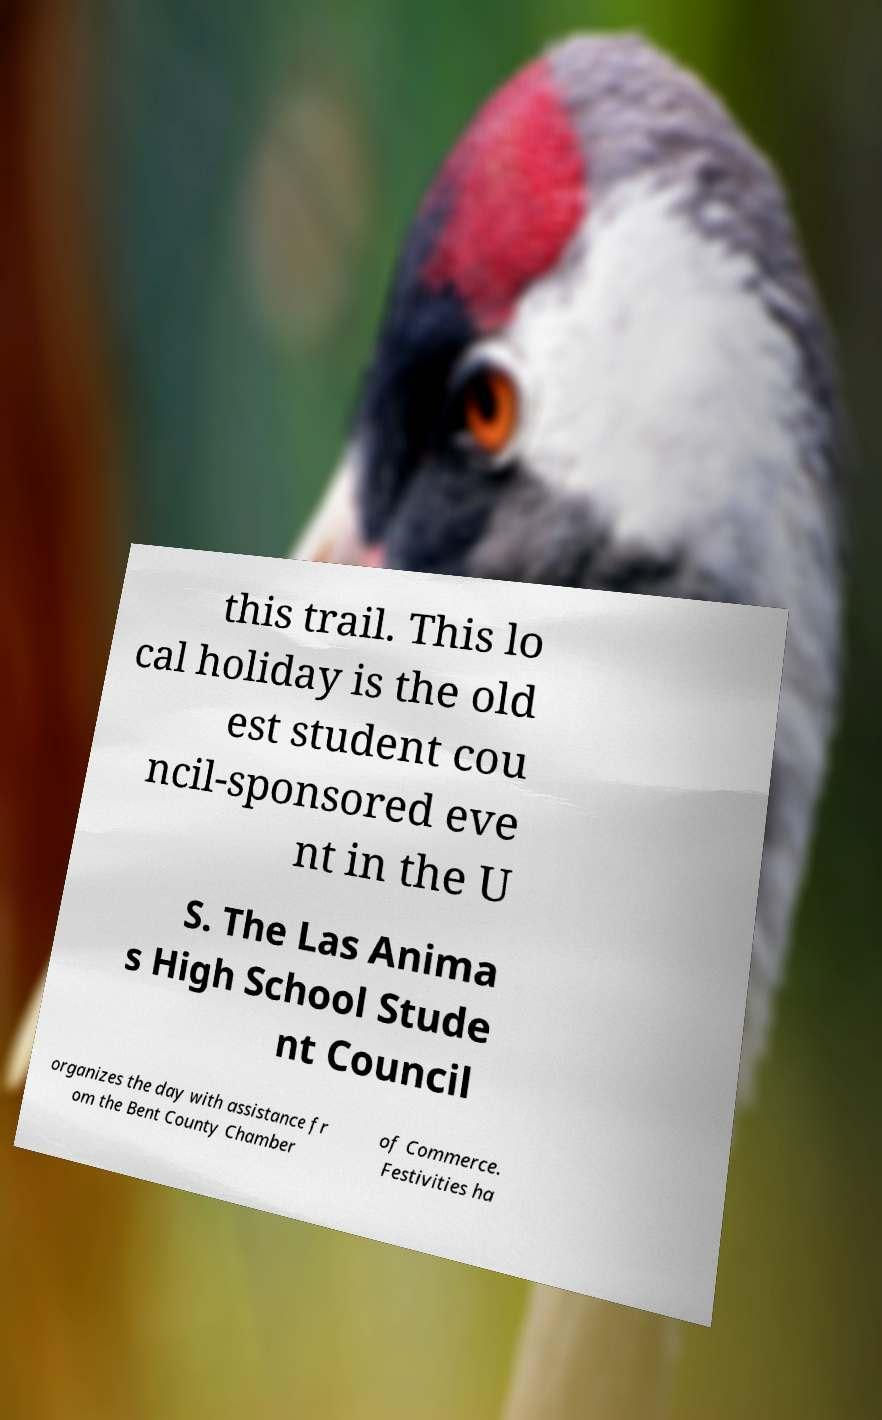What messages or text are displayed in this image? I need them in a readable, typed format. this trail. This lo cal holiday is the old est student cou ncil-sponsored eve nt in the U S. The Las Anima s High School Stude nt Council organizes the day with assistance fr om the Bent County Chamber of Commerce. Festivities ha 